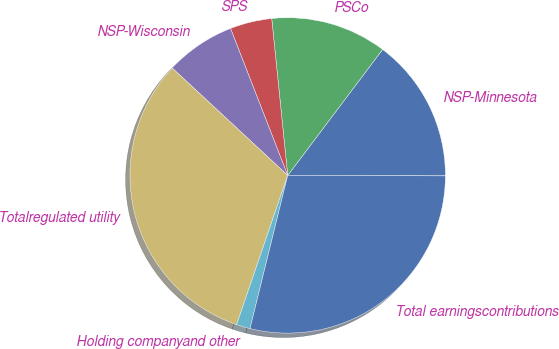Convert chart. <chart><loc_0><loc_0><loc_500><loc_500><pie_chart><fcel>NSP-Minnesota<fcel>PSCo<fcel>SPS<fcel>NSP-Wisconsin<fcel>Totalregulated utility<fcel>Holding companyand other<fcel>Total earningscontributions<nl><fcel>14.77%<fcel>11.89%<fcel>4.29%<fcel>7.17%<fcel>31.67%<fcel>1.41%<fcel>28.79%<nl></chart> 